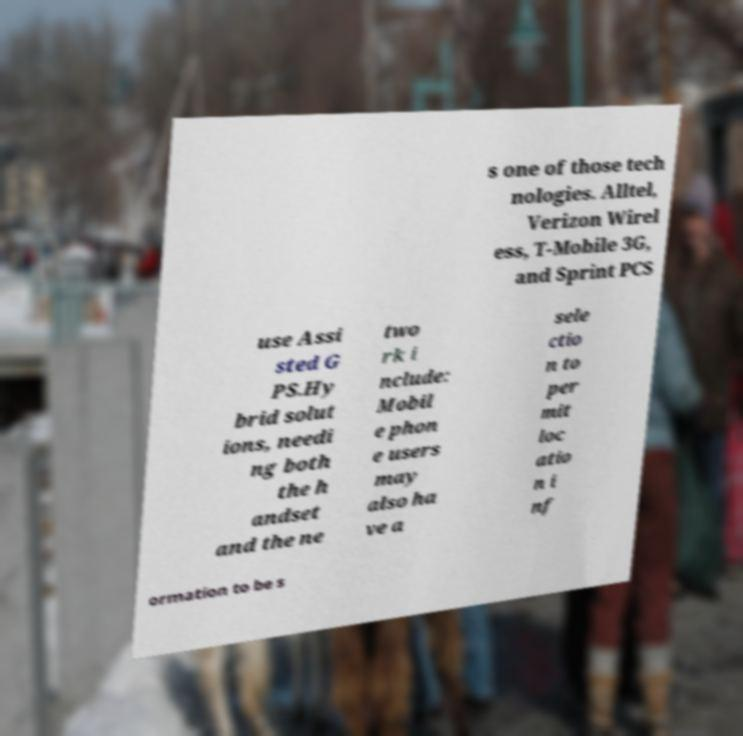For documentation purposes, I need the text within this image transcribed. Could you provide that? s one of those tech nologies. Alltel, Verizon Wirel ess, T-Mobile 3G, and Sprint PCS use Assi sted G PS.Hy brid solut ions, needi ng both the h andset and the ne two rk i nclude: Mobil e phon e users may also ha ve a sele ctio n to per mit loc atio n i nf ormation to be s 